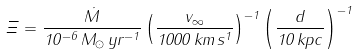<formula> <loc_0><loc_0><loc_500><loc_500>\Xi = \frac { \dot { M } } { 1 0 ^ { - 6 } \, { M } _ { \odot } \, { y r } ^ { - 1 } } \left ( \frac { v _ { \infty } } { 1 0 0 0 \, { k m } \, { s } ^ { 1 } } \right ) ^ { - 1 } \left ( \frac { d } { 1 0 \, { k p c } } \right ) ^ { - 1 }</formula> 